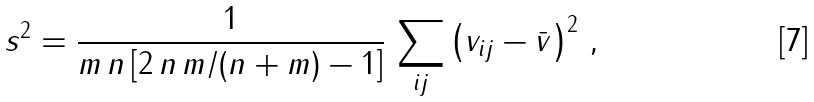<formula> <loc_0><loc_0><loc_500><loc_500>s ^ { 2 } = \frac { 1 } { m \, n \, [ 2 \, n \, m / ( n + m ) - 1 ] } \, \sum _ { i j } \left ( v _ { i j } - \bar { v } \right ) ^ { 2 } \, ,</formula> 